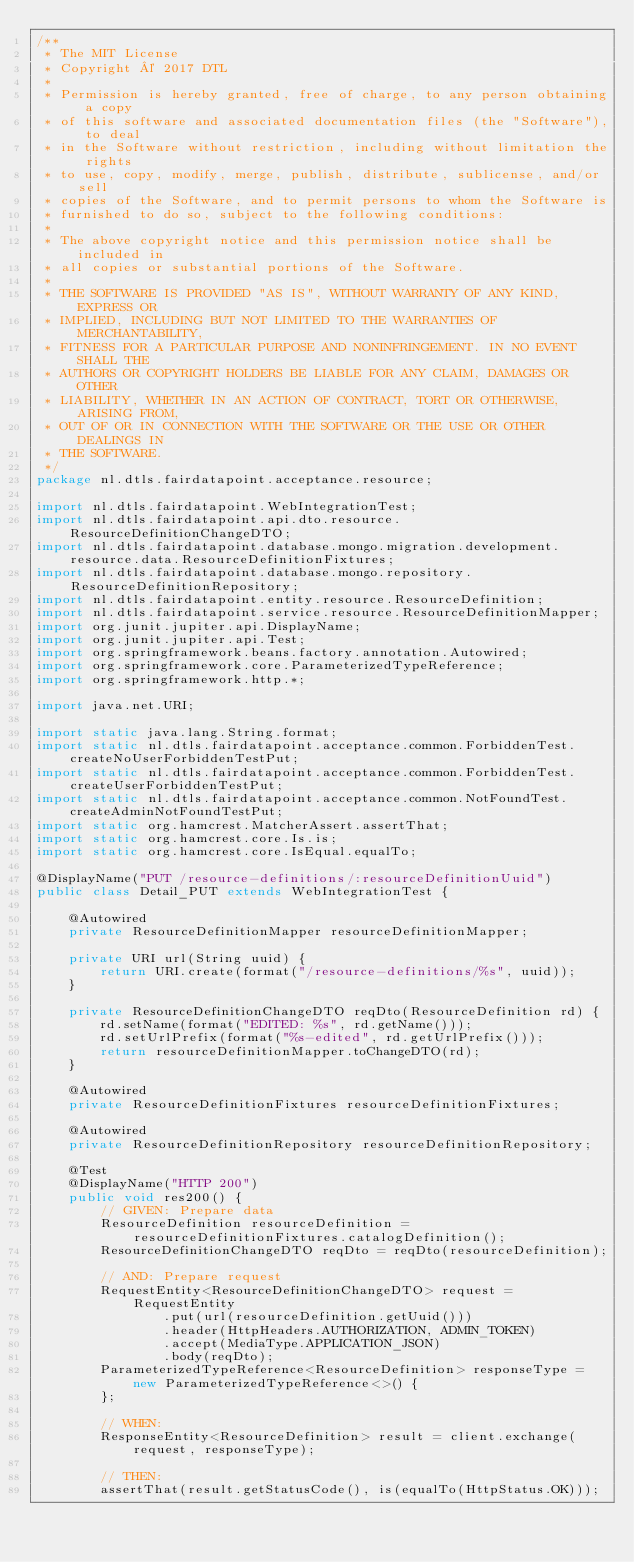<code> <loc_0><loc_0><loc_500><loc_500><_Java_>/**
 * The MIT License
 * Copyright © 2017 DTL
 *
 * Permission is hereby granted, free of charge, to any person obtaining a copy
 * of this software and associated documentation files (the "Software"), to deal
 * in the Software without restriction, including without limitation the rights
 * to use, copy, modify, merge, publish, distribute, sublicense, and/or sell
 * copies of the Software, and to permit persons to whom the Software is
 * furnished to do so, subject to the following conditions:
 *
 * The above copyright notice and this permission notice shall be included in
 * all copies or substantial portions of the Software.
 *
 * THE SOFTWARE IS PROVIDED "AS IS", WITHOUT WARRANTY OF ANY KIND, EXPRESS OR
 * IMPLIED, INCLUDING BUT NOT LIMITED TO THE WARRANTIES OF MERCHANTABILITY,
 * FITNESS FOR A PARTICULAR PURPOSE AND NONINFRINGEMENT. IN NO EVENT SHALL THE
 * AUTHORS OR COPYRIGHT HOLDERS BE LIABLE FOR ANY CLAIM, DAMAGES OR OTHER
 * LIABILITY, WHETHER IN AN ACTION OF CONTRACT, TORT OR OTHERWISE, ARISING FROM,
 * OUT OF OR IN CONNECTION WITH THE SOFTWARE OR THE USE OR OTHER DEALINGS IN
 * THE SOFTWARE.
 */
package nl.dtls.fairdatapoint.acceptance.resource;

import nl.dtls.fairdatapoint.WebIntegrationTest;
import nl.dtls.fairdatapoint.api.dto.resource.ResourceDefinitionChangeDTO;
import nl.dtls.fairdatapoint.database.mongo.migration.development.resource.data.ResourceDefinitionFixtures;
import nl.dtls.fairdatapoint.database.mongo.repository.ResourceDefinitionRepository;
import nl.dtls.fairdatapoint.entity.resource.ResourceDefinition;
import nl.dtls.fairdatapoint.service.resource.ResourceDefinitionMapper;
import org.junit.jupiter.api.DisplayName;
import org.junit.jupiter.api.Test;
import org.springframework.beans.factory.annotation.Autowired;
import org.springframework.core.ParameterizedTypeReference;
import org.springframework.http.*;

import java.net.URI;

import static java.lang.String.format;
import static nl.dtls.fairdatapoint.acceptance.common.ForbiddenTest.createNoUserForbiddenTestPut;
import static nl.dtls.fairdatapoint.acceptance.common.ForbiddenTest.createUserForbiddenTestPut;
import static nl.dtls.fairdatapoint.acceptance.common.NotFoundTest.createAdminNotFoundTestPut;
import static org.hamcrest.MatcherAssert.assertThat;
import static org.hamcrest.core.Is.is;
import static org.hamcrest.core.IsEqual.equalTo;

@DisplayName("PUT /resource-definitions/:resourceDefinitionUuid")
public class Detail_PUT extends WebIntegrationTest {

    @Autowired
    private ResourceDefinitionMapper resourceDefinitionMapper;

    private URI url(String uuid) {
        return URI.create(format("/resource-definitions/%s", uuid));
    }

    private ResourceDefinitionChangeDTO reqDto(ResourceDefinition rd) {
        rd.setName(format("EDITED: %s", rd.getName()));
        rd.setUrlPrefix(format("%s-edited", rd.getUrlPrefix()));
        return resourceDefinitionMapper.toChangeDTO(rd);
    }

    @Autowired
    private ResourceDefinitionFixtures resourceDefinitionFixtures;

    @Autowired
    private ResourceDefinitionRepository resourceDefinitionRepository;

    @Test
    @DisplayName("HTTP 200")
    public void res200() {
        // GIVEN: Prepare data
        ResourceDefinition resourceDefinition = resourceDefinitionFixtures.catalogDefinition();
        ResourceDefinitionChangeDTO reqDto = reqDto(resourceDefinition);

        // AND: Prepare request
        RequestEntity<ResourceDefinitionChangeDTO> request = RequestEntity
                .put(url(resourceDefinition.getUuid()))
                .header(HttpHeaders.AUTHORIZATION, ADMIN_TOKEN)
                .accept(MediaType.APPLICATION_JSON)
                .body(reqDto);
        ParameterizedTypeReference<ResourceDefinition> responseType = new ParameterizedTypeReference<>() {
        };

        // WHEN:
        ResponseEntity<ResourceDefinition> result = client.exchange(request, responseType);

        // THEN:
        assertThat(result.getStatusCode(), is(equalTo(HttpStatus.OK)));</code> 